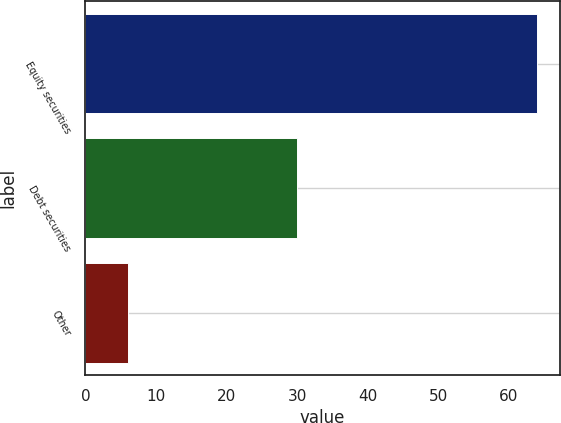<chart> <loc_0><loc_0><loc_500><loc_500><bar_chart><fcel>Equity securities<fcel>Debt securities<fcel>Other<nl><fcel>64<fcel>30<fcel>6<nl></chart> 